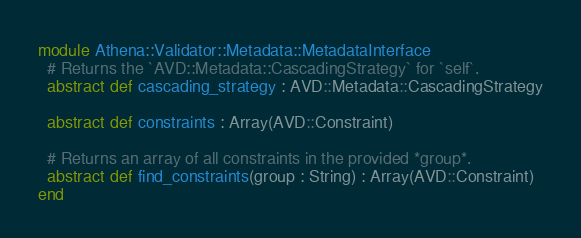Convert code to text. <code><loc_0><loc_0><loc_500><loc_500><_Crystal_>module Athena::Validator::Metadata::MetadataInterface
  # Returns the `AVD::Metadata::CascadingStrategy` for `self`.
  abstract def cascading_strategy : AVD::Metadata::CascadingStrategy

  abstract def constraints : Array(AVD::Constraint)

  # Returns an array of all constraints in the provided *group*.
  abstract def find_constraints(group : String) : Array(AVD::Constraint)
end
</code> 